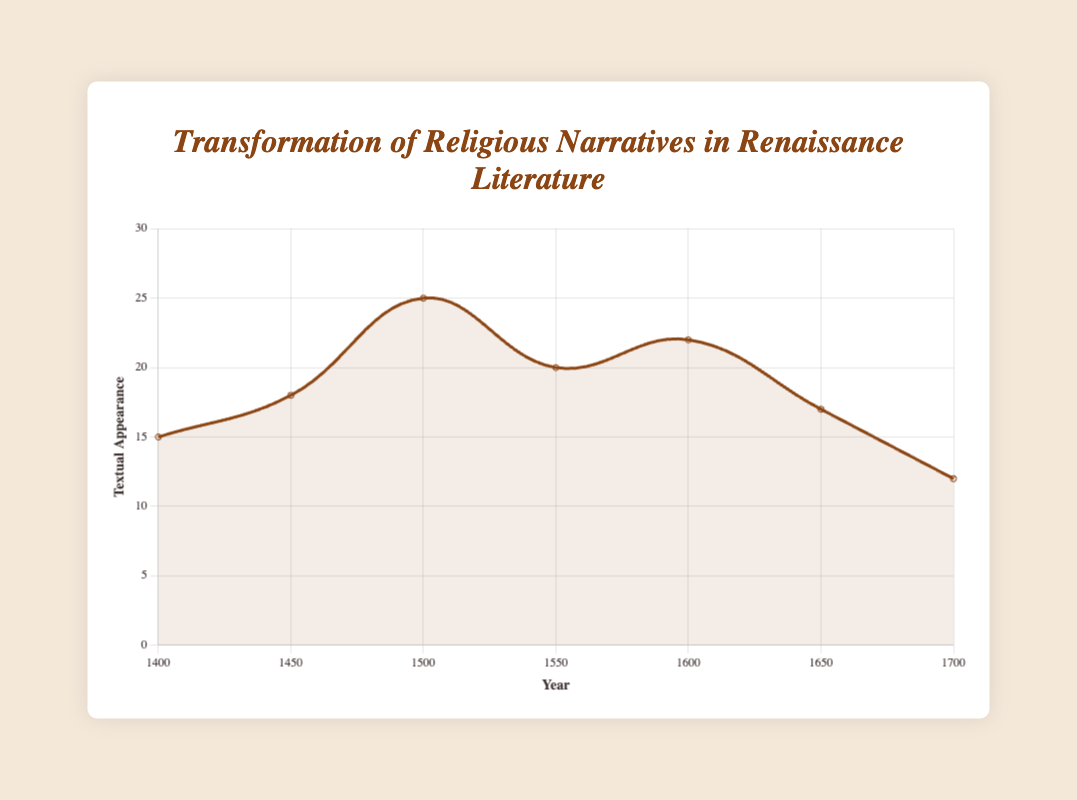What is the year with the highest textual appearance of religious themes? To find this, look at the peak point on the plotted curve. The highest point corresponds to the year 1500 with a textual appearance value of 25.
Answer: 1500 Which period showed the most substantial increase in textual appearance from the previous data point? Compare the differences for each period. The biggest increase is from 1450 to 1500 (18 to 25). The textual appearance increases by 7.
Answer: 1450 to 1500 By how much does the textual appearance decrease from 1600 to 1700? Find the textual appearance for 1600 (22) and for 1700 (12), then subtract 12 from 22: 22 - 12 = 10.
Answer: 10 Between which years did the textual appearance remain relatively stable (smallest change)? Compare differences between adjacent data points. The smallest change is from 1650 to 1700 with a decline of 5 (17 to 12).
Answer: 1650 to 1700 How does the textual appearance in 1650 compare to that in 1400? Look at the data points for 1400 (15) and 1650 (17). The textual appearance in 1650 is higher by 2.
Answer: Higher by 2 What is the average textual appearance between 1400 and 1600? Sum the textual appearances for 1400, 1450, 1500, and 1600: 15 + 18 + 25 + 22 = 80. Divide by the number of years (4): 80/4 = 20.
Answer: 20 Identify the trend in textual appearance from 1500 to 1700. Observe the curve from 1500 (25) to 1700 (12). It shows a declining trend.
Answer: Decline What can be inferred about humanism and religious narratives around 1550 based on the figure? The textual appearance in 1550 is 20, which is slightly lower than the peak in 1500 but still relatively high. This suggests that humanism and religious narratives were prominent but starting to decline.
Answer: High but starting to decline 